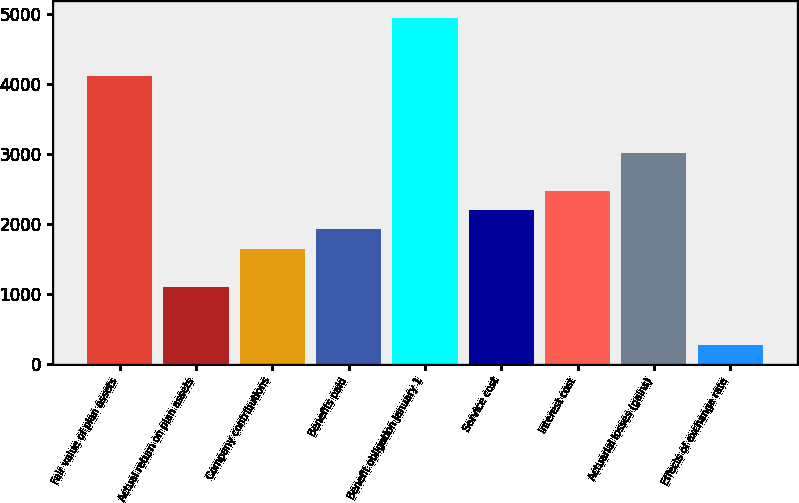Convert chart. <chart><loc_0><loc_0><loc_500><loc_500><bar_chart><fcel>Fair value of plan assets<fcel>Actual return on plan assets<fcel>Company contributions<fcel>Benefits paid<fcel>Benefit obligation January 1<fcel>Service cost<fcel>Interest cost<fcel>Actuarial losses (gains)<fcel>Effects of exchange rate<nl><fcel>4116.5<fcel>1099.2<fcel>1647.8<fcel>1922.1<fcel>4939.4<fcel>2196.4<fcel>2470.7<fcel>3019.3<fcel>276.3<nl></chart> 